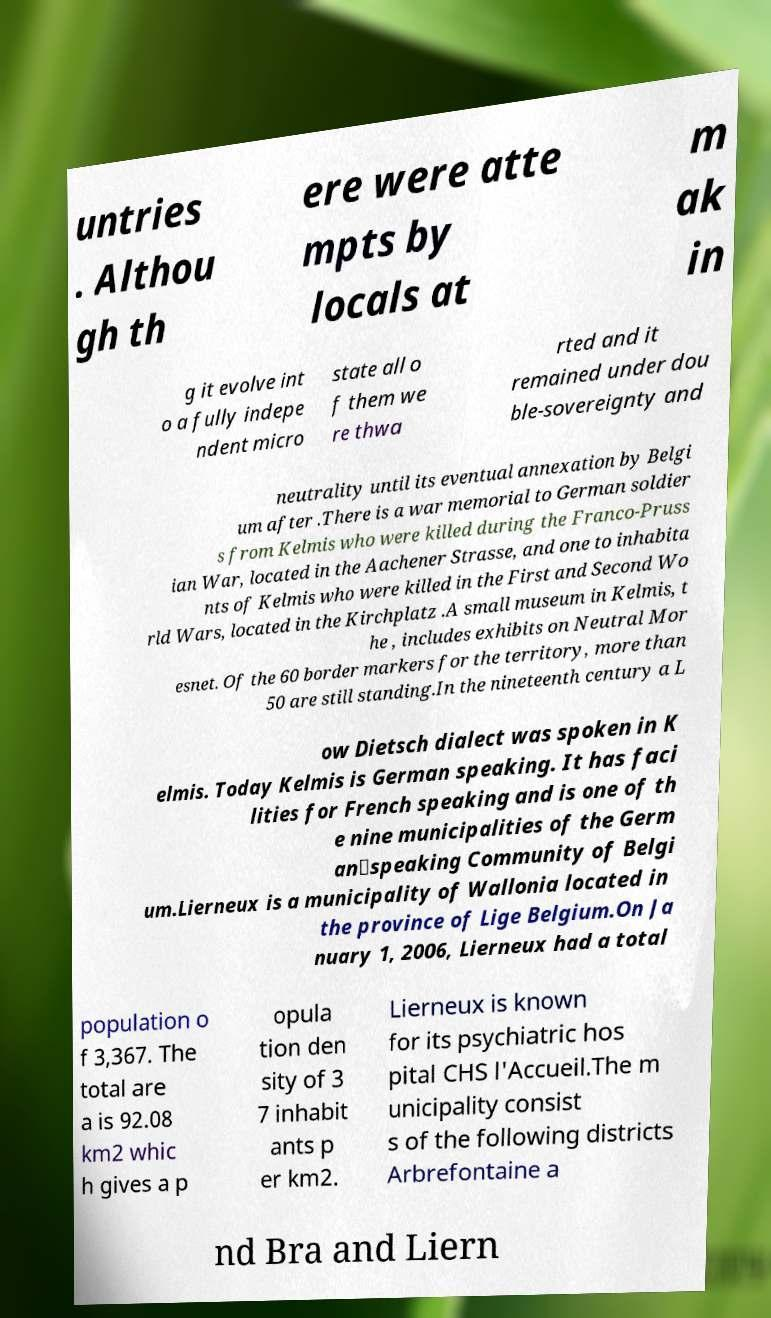Can you read and provide the text displayed in the image?This photo seems to have some interesting text. Can you extract and type it out for me? untries . Althou gh th ere were atte mpts by locals at m ak in g it evolve int o a fully indepe ndent micro state all o f them we re thwa rted and it remained under dou ble-sovereignty and neutrality until its eventual annexation by Belgi um after .There is a war memorial to German soldier s from Kelmis who were killed during the Franco-Pruss ian War, located in the Aachener Strasse, and one to inhabita nts of Kelmis who were killed in the First and Second Wo rld Wars, located in the Kirchplatz .A small museum in Kelmis, t he , includes exhibits on Neutral Mor esnet. Of the 60 border markers for the territory, more than 50 are still standing.In the nineteenth century a L ow Dietsch dialect was spoken in K elmis. Today Kelmis is German speaking. It has faci lities for French speaking and is one of th e nine municipalities of the Germ an‑speaking Community of Belgi um.Lierneux is a municipality of Wallonia located in the province of Lige Belgium.On Ja nuary 1, 2006, Lierneux had a total population o f 3,367. The total are a is 92.08 km2 whic h gives a p opula tion den sity of 3 7 inhabit ants p er km2. Lierneux is known for its psychiatric hos pital CHS l'Accueil.The m unicipality consist s of the following districts Arbrefontaine a nd Bra and Liern 